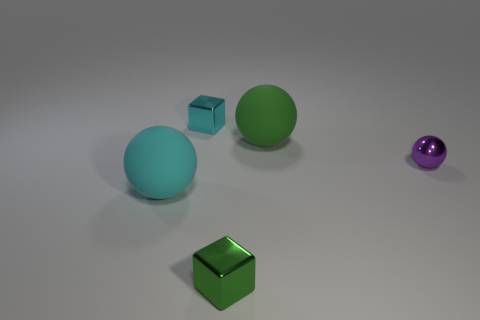What's the overall mood or style conveyed by the arrangement of these objects? The image conveys a minimalist and modern style, with a clean background that emphasizes the geometric shapes and the contrasting colors of the objects. The lighting is soft and even, creating a tranquil and somewhat contemplative mood. 